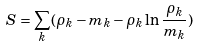Convert formula to latex. <formula><loc_0><loc_0><loc_500><loc_500>S = \sum _ { k } ( \rho _ { k } - m _ { k } - \rho _ { k } \ln \frac { \rho _ { k } } { m _ { k } } )</formula> 